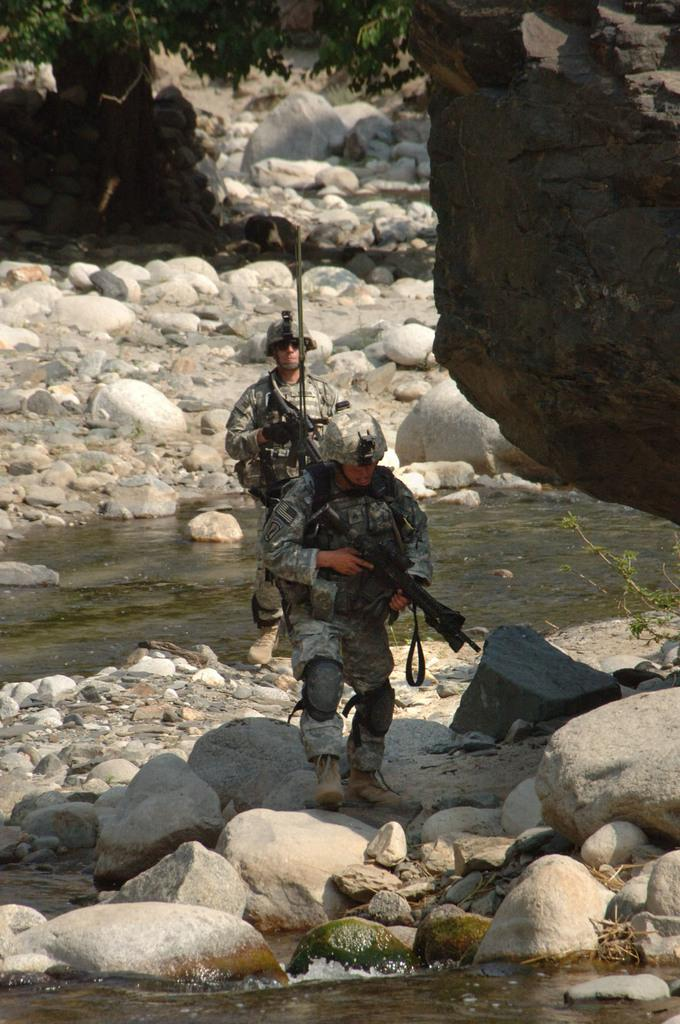How many people are in the image? There are two persons in the image. What is visible in the image besides the people? Water and rocks are visible in the image. What can be seen in the background of the image? There are trees in the background of the image. What type of sheet is being used to catch the fish in the image? There is no sheet or fishing activity present in the image. What trick is being performed by the persons in the image? There is no trick being performed by the persons in the image. 